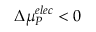Convert formula to latex. <formula><loc_0><loc_0><loc_500><loc_500>\Delta { \mu } _ { P } ^ { e l e c } < 0</formula> 